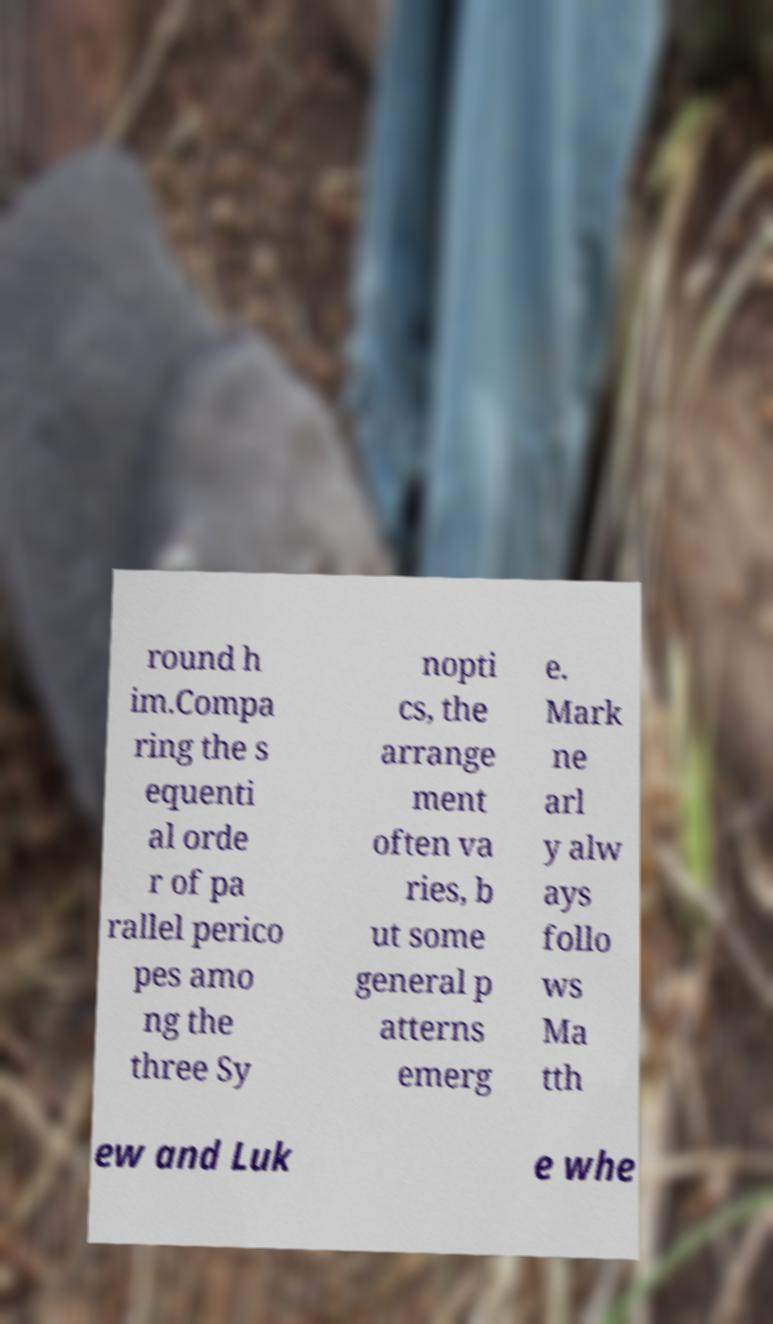What messages or text are displayed in this image? I need them in a readable, typed format. round h im.Compa ring the s equenti al orde r of pa rallel perico pes amo ng the three Sy nopti cs, the arrange ment often va ries, b ut some general p atterns emerg e. Mark ne arl y alw ays follo ws Ma tth ew and Luk e whe 